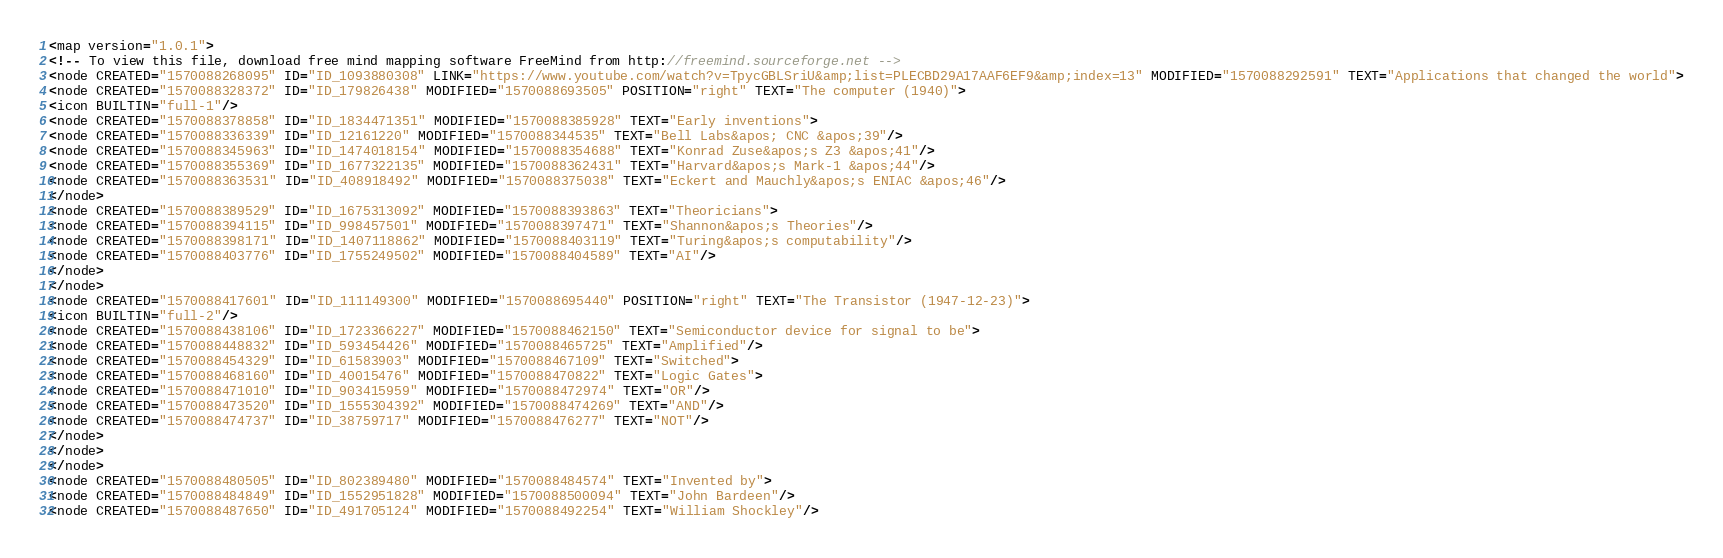<code> <loc_0><loc_0><loc_500><loc_500><_ObjectiveC_><map version="1.0.1">
<!-- To view this file, download free mind mapping software FreeMind from http://freemind.sourceforge.net -->
<node CREATED="1570088268095" ID="ID_1093880308" LINK="https://www.youtube.com/watch?v=TpycGBLSriU&amp;list=PLECBD29A17AAF6EF9&amp;index=13" MODIFIED="1570088292591" TEXT="Applications that changed the world">
<node CREATED="1570088328372" ID="ID_179826438" MODIFIED="1570088693505" POSITION="right" TEXT="The computer (1940)">
<icon BUILTIN="full-1"/>
<node CREATED="1570088378858" ID="ID_1834471351" MODIFIED="1570088385928" TEXT="Early inventions">
<node CREATED="1570088336339" ID="ID_12161220" MODIFIED="1570088344535" TEXT="Bell Labs&apos; CNC &apos;39"/>
<node CREATED="1570088345963" ID="ID_1474018154" MODIFIED="1570088354688" TEXT="Konrad Zuse&apos;s Z3 &apos;41"/>
<node CREATED="1570088355369" ID="ID_1677322135" MODIFIED="1570088362431" TEXT="Harvard&apos;s Mark-1 &apos;44"/>
<node CREATED="1570088363531" ID="ID_408918492" MODIFIED="1570088375038" TEXT="Eckert and Mauchly&apos;s ENIAC &apos;46"/>
</node>
<node CREATED="1570088389529" ID="ID_1675313092" MODIFIED="1570088393863" TEXT="Theoricians">
<node CREATED="1570088394115" ID="ID_998457501" MODIFIED="1570088397471" TEXT="Shannon&apos;s Theories"/>
<node CREATED="1570088398171" ID="ID_1407118862" MODIFIED="1570088403119" TEXT="Turing&apos;s computability"/>
<node CREATED="1570088403776" ID="ID_1755249502" MODIFIED="1570088404589" TEXT="AI"/>
</node>
</node>
<node CREATED="1570088417601" ID="ID_111149300" MODIFIED="1570088695440" POSITION="right" TEXT="The Transistor (1947-12-23)">
<icon BUILTIN="full-2"/>
<node CREATED="1570088438106" ID="ID_1723366227" MODIFIED="1570088462150" TEXT="Semiconductor device for signal to be">
<node CREATED="1570088448832" ID="ID_593454426" MODIFIED="1570088465725" TEXT="Amplified"/>
<node CREATED="1570088454329" ID="ID_61583903" MODIFIED="1570088467109" TEXT="Switched">
<node CREATED="1570088468160" ID="ID_40015476" MODIFIED="1570088470822" TEXT="Logic Gates">
<node CREATED="1570088471010" ID="ID_903415959" MODIFIED="1570088472974" TEXT="OR"/>
<node CREATED="1570088473520" ID="ID_1555304392" MODIFIED="1570088474269" TEXT="AND"/>
<node CREATED="1570088474737" ID="ID_38759717" MODIFIED="1570088476277" TEXT="NOT"/>
</node>
</node>
</node>
<node CREATED="1570088480505" ID="ID_802389480" MODIFIED="1570088484574" TEXT="Invented by">
<node CREATED="1570088484849" ID="ID_1552951828" MODIFIED="1570088500094" TEXT="John Bardeen"/>
<node CREATED="1570088487650" ID="ID_491705124" MODIFIED="1570088492254" TEXT="William Shockley"/></code> 